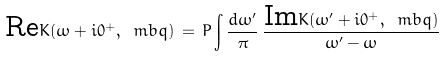Convert formula to latex. <formula><loc_0><loc_0><loc_500><loc_500>\text {Re} K ( \omega + i 0 ^ { + } , \ m b q ) \, = \, P \int \frac { d \omega ^ { \prime } } { \pi } \, \frac { \text {Im} K ( \omega ^ { \prime } + i 0 ^ { + } , \ m b q ) } { \omega ^ { \prime } - \omega }</formula> 